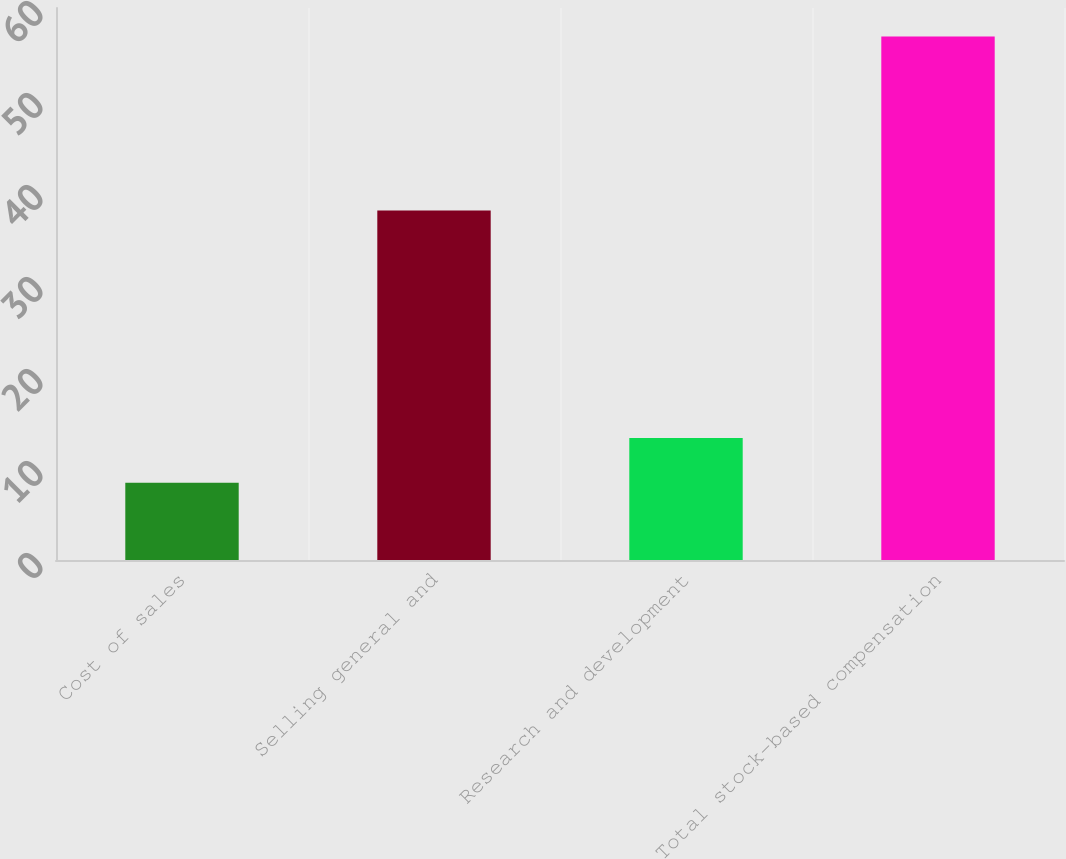<chart> <loc_0><loc_0><loc_500><loc_500><bar_chart><fcel>Cost of sales<fcel>Selling general and<fcel>Research and development<fcel>Total stock-based compensation<nl><fcel>8.4<fcel>38<fcel>13.25<fcel>56.9<nl></chart> 